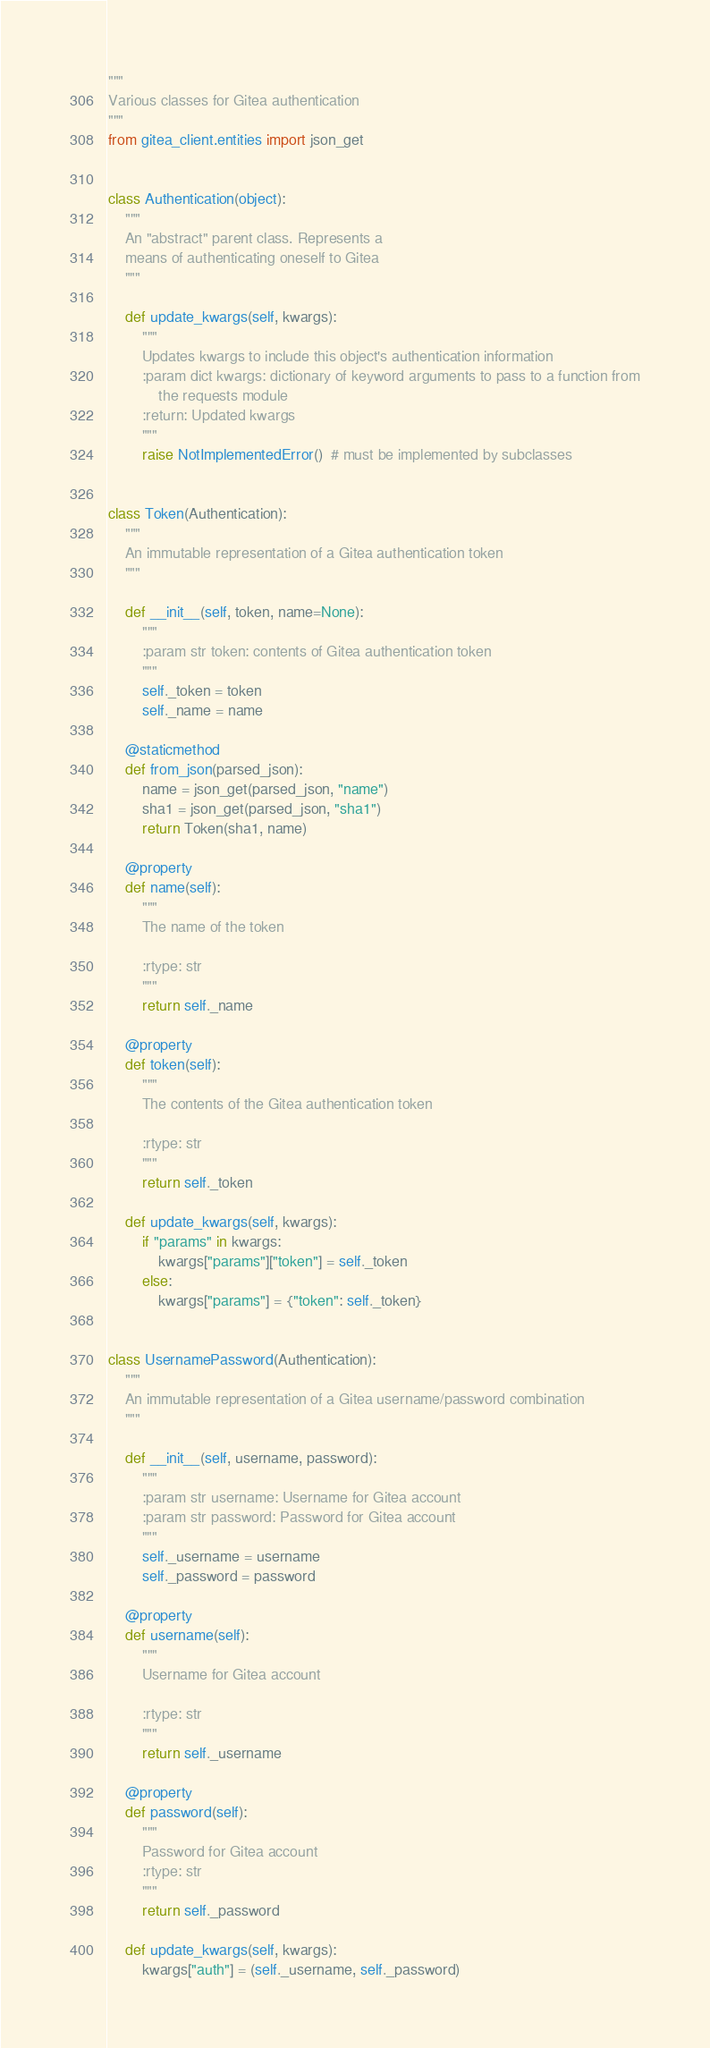<code> <loc_0><loc_0><loc_500><loc_500><_Python_>"""
Various classes for Gitea authentication
"""
from gitea_client.entities import json_get


class Authentication(object):
    """
    An "abstract" parent class. Represents a
    means of authenticating oneself to Gitea
    """

    def update_kwargs(self, kwargs):
        """
        Updates kwargs to include this object's authentication information
        :param dict kwargs: dictionary of keyword arguments to pass to a function from
            the requests module
        :return: Updated kwargs
        """
        raise NotImplementedError()  # must be implemented by subclasses


class Token(Authentication):
    """
    An immutable representation of a Gitea authentication token
    """

    def __init__(self, token, name=None):
        """
        :param str token: contents of Gitea authentication token
        """
        self._token = token
        self._name = name

    @staticmethod
    def from_json(parsed_json):
        name = json_get(parsed_json, "name")
        sha1 = json_get(parsed_json, "sha1")
        return Token(sha1, name)

    @property
    def name(self):
        """
        The name of the token

        :rtype: str
        """
        return self._name

    @property
    def token(self):
        """
        The contents of the Gitea authentication token

        :rtype: str
        """
        return self._token

    def update_kwargs(self, kwargs):
        if "params" in kwargs:
            kwargs["params"]["token"] = self._token
        else:
            kwargs["params"] = {"token": self._token}


class UsernamePassword(Authentication):
    """
    An immutable representation of a Gitea username/password combination
    """

    def __init__(self, username, password):
        """
        :param str username: Username for Gitea account
        :param str password: Password for Gitea account
        """
        self._username = username
        self._password = password

    @property
    def username(self):
        """
        Username for Gitea account

        :rtype: str
        """
        return self._username

    @property
    def password(self):
        """
        Password for Gitea account
        :rtype: str
        """
        return self._password

    def update_kwargs(self, kwargs):
        kwargs["auth"] = (self._username, self._password)
</code> 